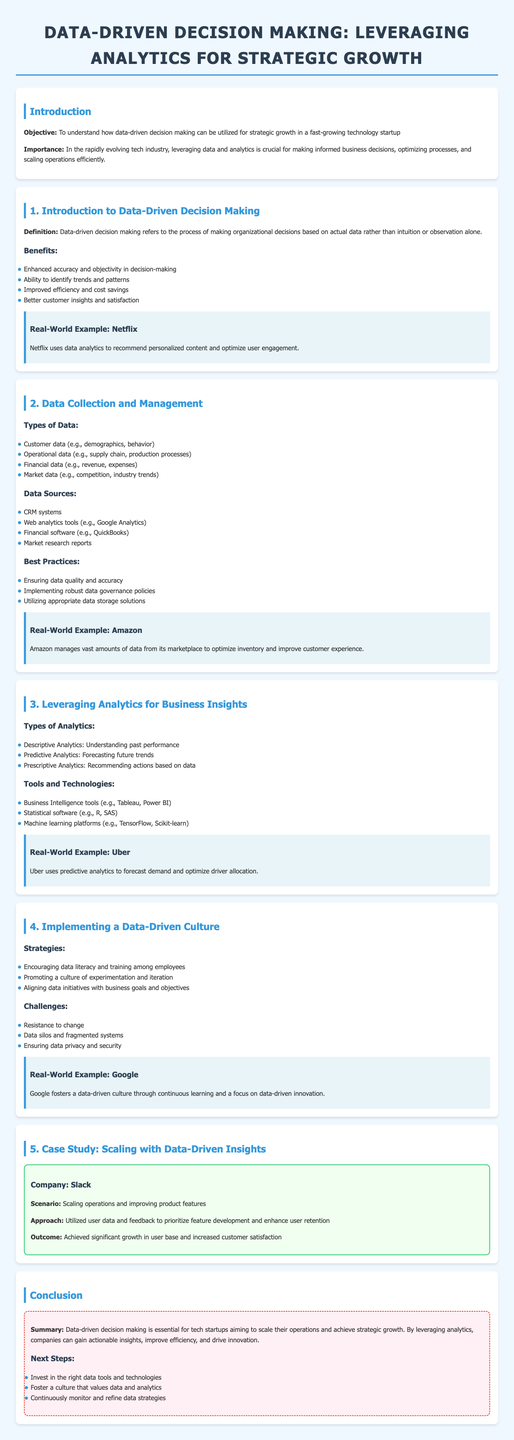What is the objective of the lesson? The objective is to understand how data-driven decision making can be utilized for strategic growth in a fast-growing technology startup.
Answer: To understand how data-driven decision making can be utilized for strategic growth in a fast-growing technology startup What company is mentioned as a real-world example of data analytics usage for content recommendations? The document provides Netflix as an example of using data analytics for personalized content recommendations.
Answer: Netflix What are the four types of data mentioned in the document? The document lists customer data, operational data, financial data, and market data as the types of data.
Answer: Customer, operational, financial, market What is one of the challenges in implementing a data-driven culture? The document specifies resistance to change as a challenge in implementing a data-driven culture.
Answer: Resistance to change What is described as the approach used by Slack in the case study? Slack utilized user data and feedback to prioritize feature development and enhance user retention.
Answer: Utilized user data and feedback to prioritize feature development and enhance user retention What type of analytics is used to forecast future trends? The document identifies predictive analytics as the type of analytics used for forecasting future trends.
Answer: Predictive Analytics What should companies invest in as a next step according to the conclusion? The document advises companies to invest in the right data tools and technologies as a next step.
Answer: Invest in the right data tools and technologies How are decision-making processes characterized in data-driven decision making? The document characterizes the decision-making process as being based on actual data rather than intuition or observation alone.
Answer: Based on actual data rather than intuition or observation alone What color is used for the section headings? The document states that the section headings are colored in a specific shade, which is a shade of blue.
Answer: Blue 